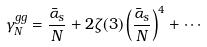Convert formula to latex. <formula><loc_0><loc_0><loc_500><loc_500>\gamma _ { N } ^ { g g } = \frac { \bar { \alpha } _ { s } } { N } + 2 \zeta ( 3 ) \left ( \frac { \bar { \alpha } _ { s } } { N } \right ) ^ { 4 } + \cdots</formula> 